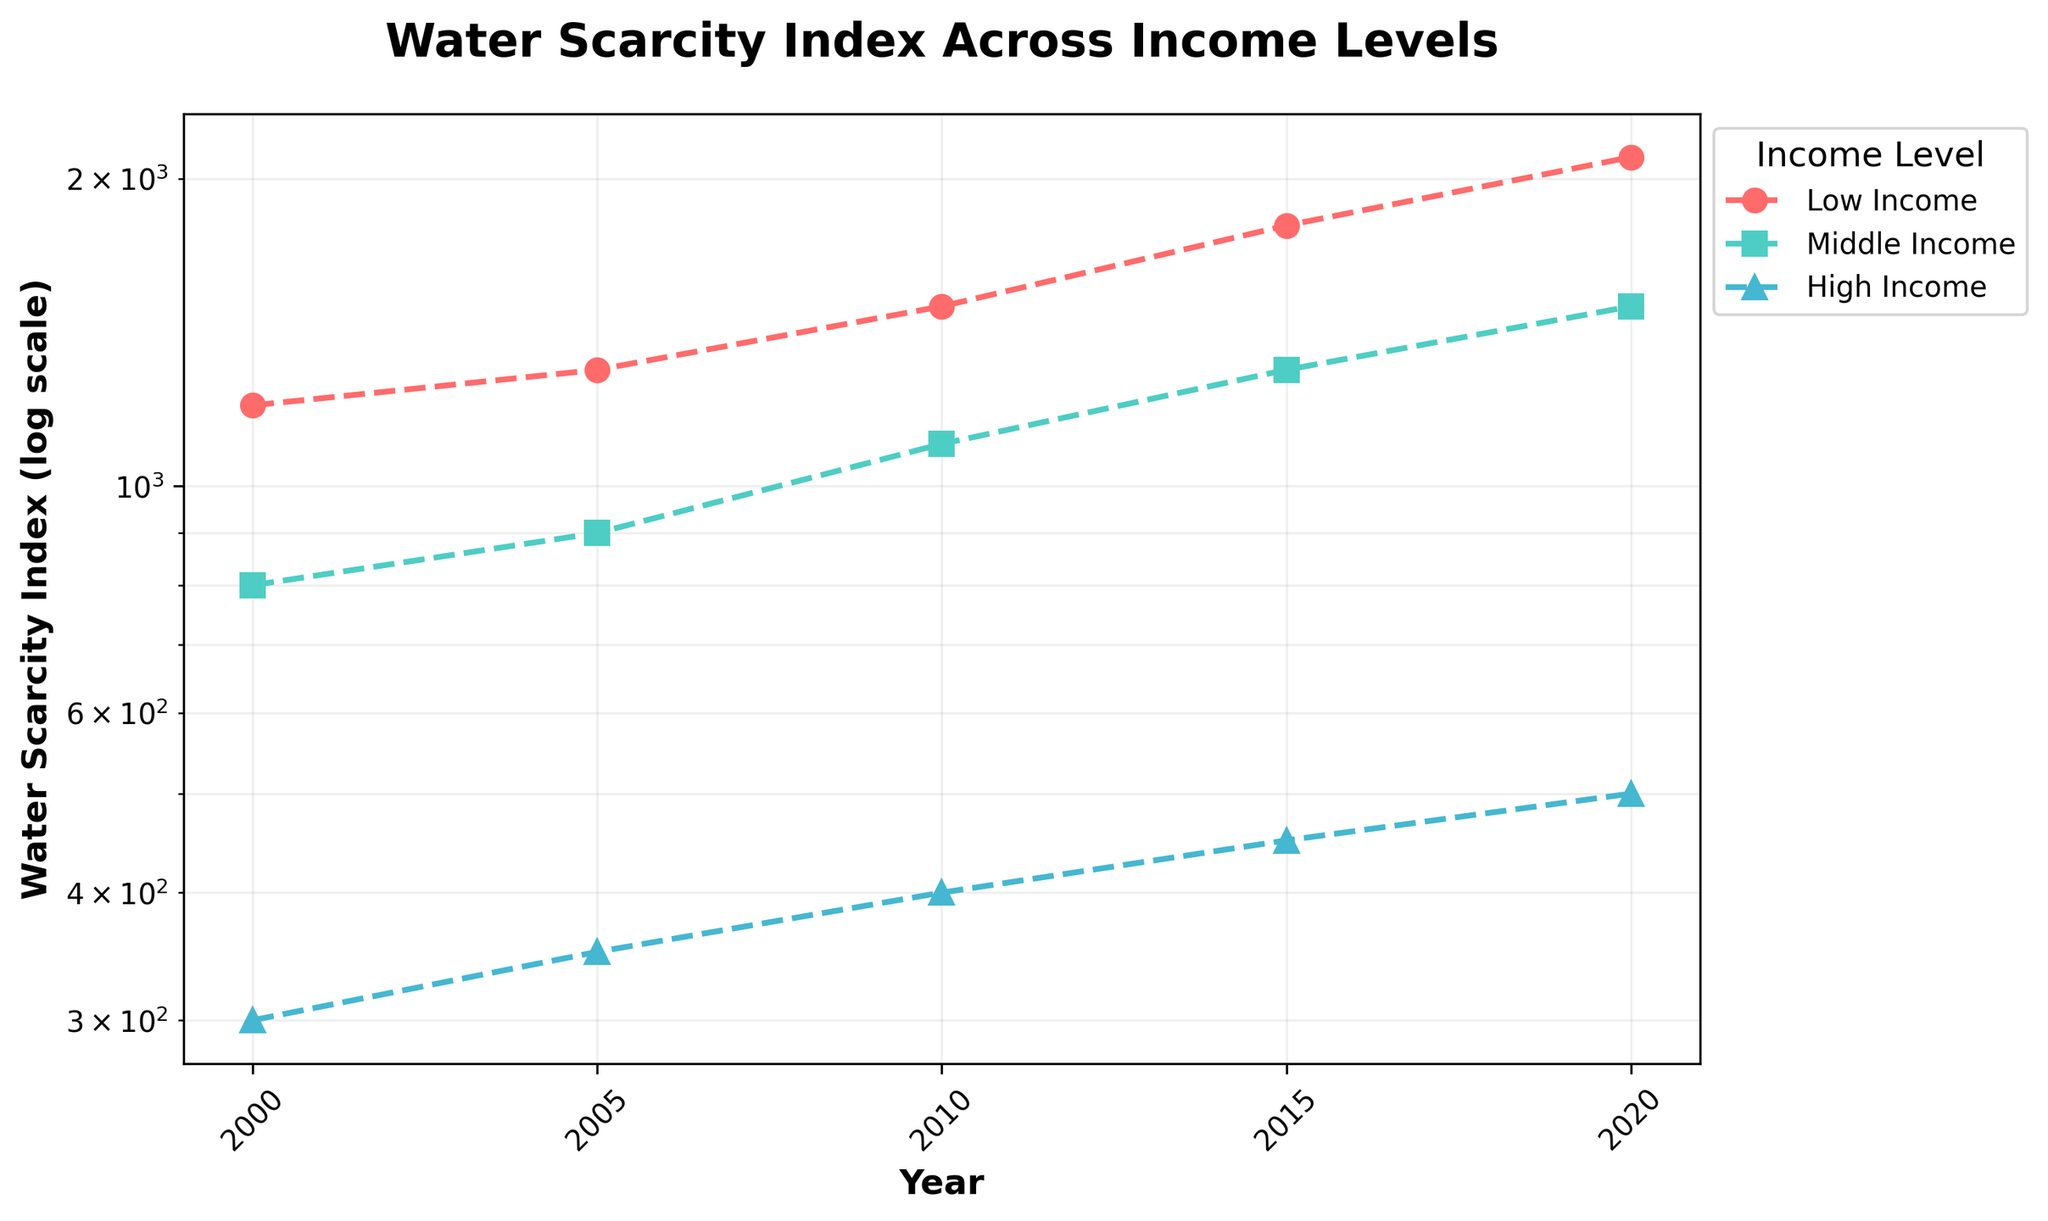What is the title of the plot? The title of the plot is typically located at the top center, displaying the main topic or focus of the plot. Here, the title is "Water Scarcity Index Across Income Levels".
Answer: Water Scarcity Index Across Income Levels How many different income levels are represented in the plot? The legend on the right side of the plot indicates the different groups by their labels. Three income levels are represented: Low Income, Middle Income, and High Income.
Answer: Three Which income level shows the largest increase in Water Scarcity Index from 2000 to 2020? By observing the plotted lines from 2000 to 2020 for each income level, the Low Income group shows the steepest increase in the Water Scarcity Index.
Answer: Low Income What is the Water Scarcity Index for High-Income level in 2020? The data point corresponding to the year 2020 for the High Income group on the plot indicates a Water Scarcity Index of 500.
Answer: 500 What is the trend of the Water Scarcity Index for Middle Income between 2000 and 2020? Observing the points and line specific to the Middle Income group from 2000 to 2020, the index shows an upward trend, increasing from 800 in 2000 to 1500 in 2020.
Answer: Upward Compare the Water Scarcity Index for Low Income and High Income in 2010. Which one is higher and by how much? The point for Low Income in 2010 is at 1500, and for High Income, it's at 400. The difference is 1500 - 400 = 1100.
Answer: Low Income, by 1100 Has the Water Scarcity Index for Middle Income always stayed above High Income from 2000 to 2020? By comparing the Middle Income line with the High Income line through all the years on the plot, you can see that Middle Income is consistently higher.
Answer: Yes Using the log scale on the y-axis, what is the approximate difference in orders of magnitude in Water Scarcity Index between Low Income and High Income in 2020? The y-axis with the log scale allows us to see that Low Income is roughly one order of magnitude higher than High Income in 2020, with index values of approximately 2100 and 500, respectively.
Answer: One order of magnitude What was the value of the Water Scarcity Index for Low Income in 2015, and what does it approximate to on a log scale? In 2015, the Water Scarcity Index for Low Income is at 1800, which on a log scale approximates to slightly above 10^3.
Answer: Slightly above 10^3 